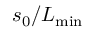<formula> <loc_0><loc_0><loc_500><loc_500>s _ { 0 } / L _ { \min }</formula> 